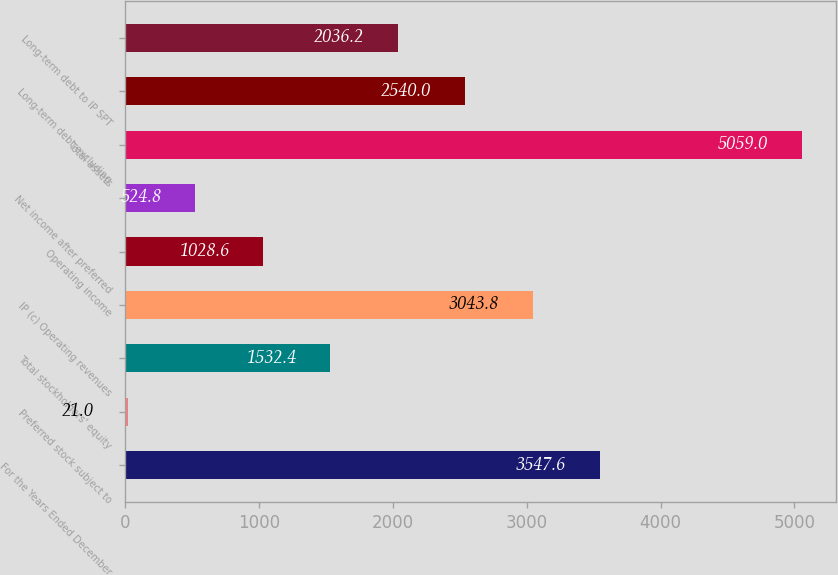Convert chart. <chart><loc_0><loc_0><loc_500><loc_500><bar_chart><fcel>For the Years Ended December<fcel>Preferred stock subject to<fcel>Total stockholders' equity<fcel>IP (c) Operating revenues<fcel>Operating income<fcel>Net income after preferred<fcel>Total assets<fcel>Long-term debt excluding<fcel>Long-term debt to IP SPT<nl><fcel>3547.6<fcel>21<fcel>1532.4<fcel>3043.8<fcel>1028.6<fcel>524.8<fcel>5059<fcel>2540<fcel>2036.2<nl></chart> 